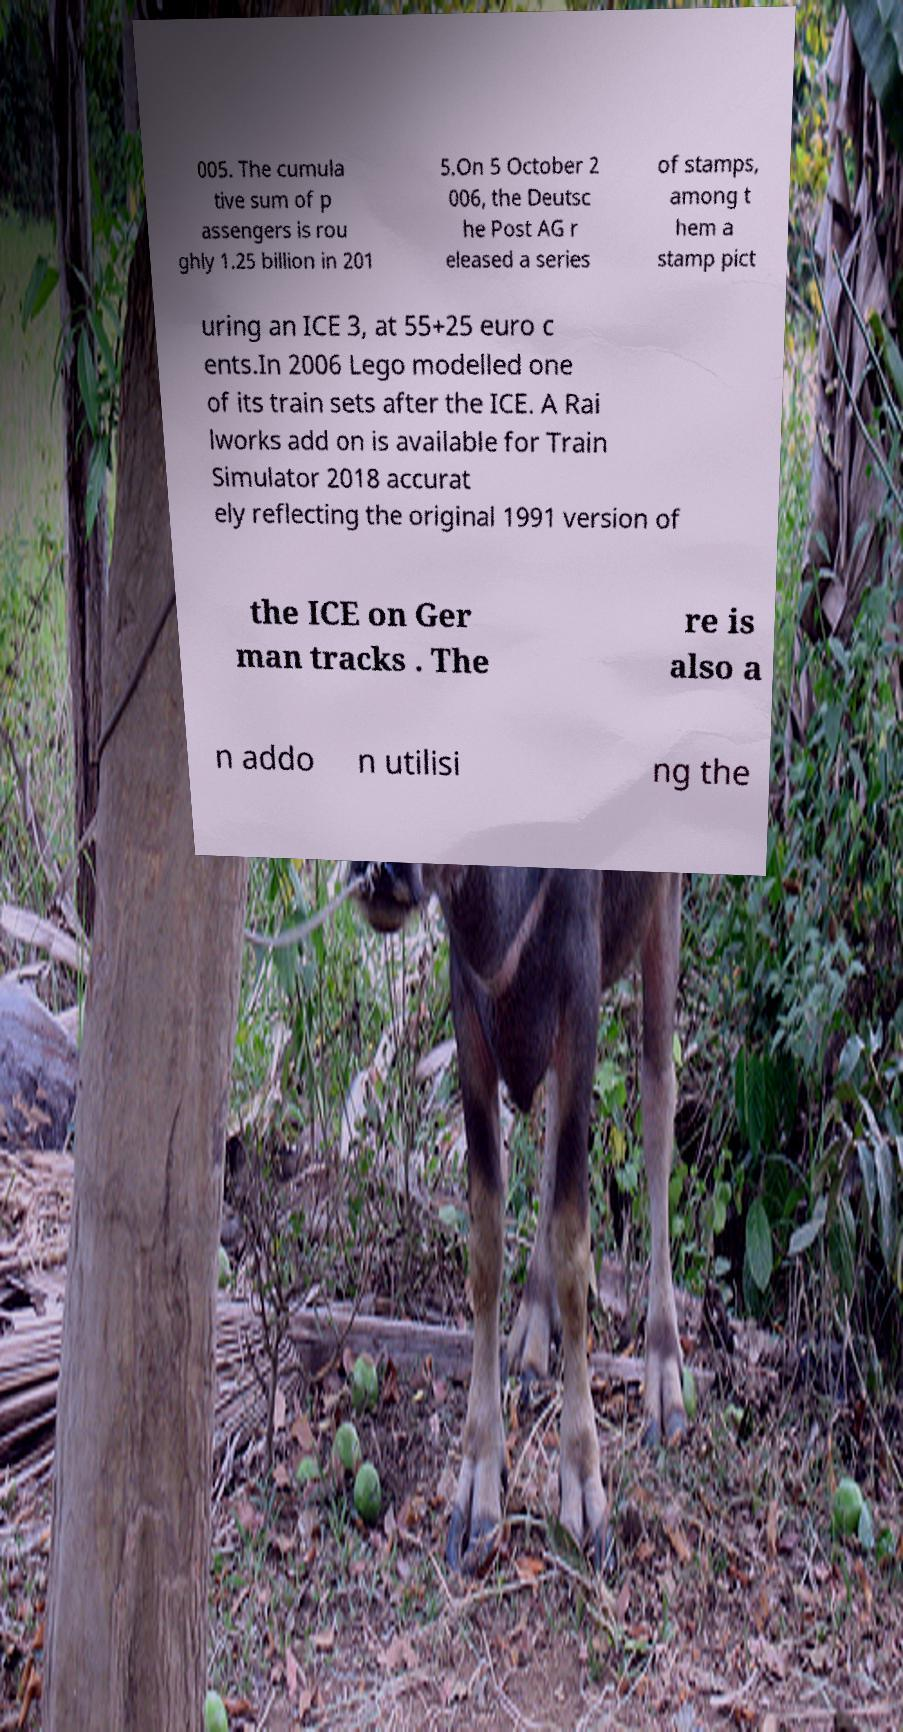I need the written content from this picture converted into text. Can you do that? 005. The cumula tive sum of p assengers is rou ghly 1.25 billion in 201 5.On 5 October 2 006, the Deutsc he Post AG r eleased a series of stamps, among t hem a stamp pict uring an ICE 3, at 55+25 euro c ents.In 2006 Lego modelled one of its train sets after the ICE. A Rai lworks add on is available for Train Simulator 2018 accurat ely reflecting the original 1991 version of the ICE on Ger man tracks . The re is also a n addo n utilisi ng the 